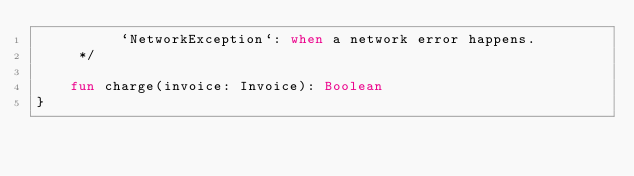Convert code to text. <code><loc_0><loc_0><loc_500><loc_500><_Kotlin_>          `NetworkException`: when a network error happens.
     */

    fun charge(invoice: Invoice): Boolean
}
</code> 